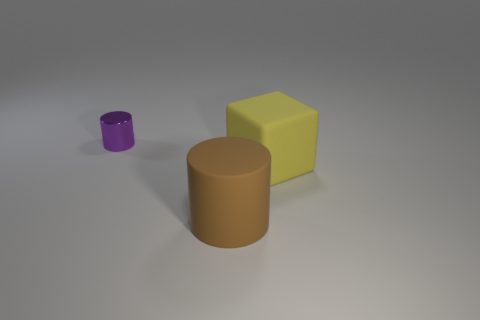Does the cylinder that is behind the large yellow matte cube have the same material as the cylinder to the right of the tiny metal cylinder?
Keep it short and to the point. No. What is the small purple cylinder made of?
Ensure brevity in your answer.  Metal. What number of other things are the same color as the matte cube?
Your answer should be compact. 0. Is the big cylinder the same color as the small metal thing?
Your response must be concise. No. How many small shiny spheres are there?
Your answer should be compact. 0. There is a cylinder in front of the small purple shiny object behind the big brown rubber cylinder; what is it made of?
Give a very brief answer. Rubber. What is the material of the brown cylinder that is the same size as the yellow matte object?
Your answer should be very brief. Rubber. There is a thing that is left of the brown matte cylinder; is its size the same as the rubber cylinder?
Offer a very short reply. No. Do the large rubber object on the left side of the big rubber block and the tiny purple thing have the same shape?
Your answer should be very brief. Yes. How many things are either yellow matte objects or big objects that are behind the big brown rubber cylinder?
Keep it short and to the point. 1. 